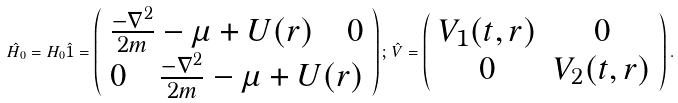<formula> <loc_0><loc_0><loc_500><loc_500>\hat { H } _ { 0 } = H _ { 0 } \hat { 1 } = \left ( \begin{array} { c } \frac { - \nabla ^ { 2 } } { 2 m } - \mu + U ( { r } ) \quad 0 \\ 0 \quad \frac { - \nabla ^ { 2 } } { 2 m } - \mu + U ( { r } ) \end{array} \right ) ; \, \hat { V } = \left ( \begin{array} { c c } V _ { 1 } ( t , { r } ) & 0 \\ 0 & V _ { 2 } ( t , { r } ) \end{array} \right ) .</formula> 